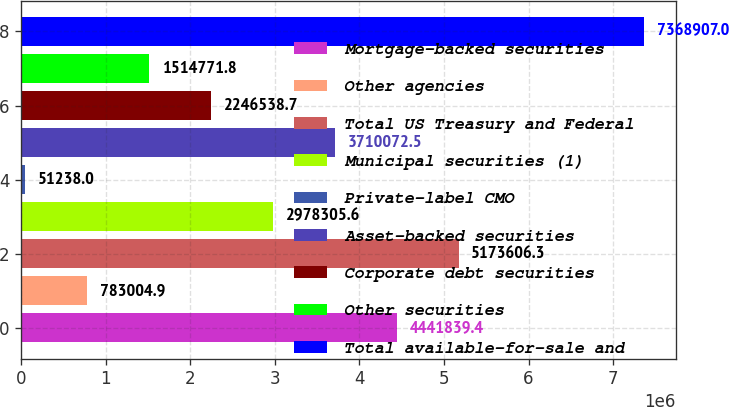<chart> <loc_0><loc_0><loc_500><loc_500><bar_chart><fcel>Mortgage-backed securities<fcel>Other agencies<fcel>Total US Treasury and Federal<fcel>Municipal securities (1)<fcel>Private-label CMO<fcel>Asset-backed securities<fcel>Corporate debt securities<fcel>Other securities<fcel>Total available-for-sale and<nl><fcel>4.44184e+06<fcel>783005<fcel>5.17361e+06<fcel>2.97831e+06<fcel>51238<fcel>3.71007e+06<fcel>2.24654e+06<fcel>1.51477e+06<fcel>7.36891e+06<nl></chart> 